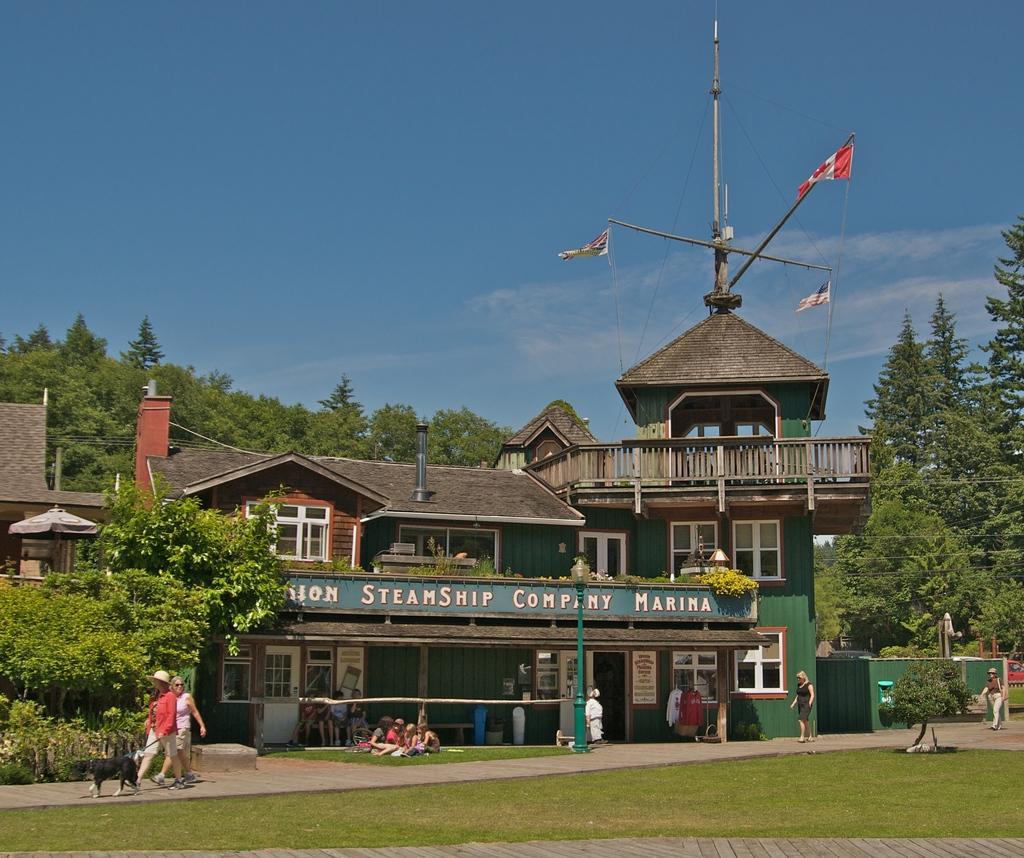Could you give a brief overview of what you see in this image? In this image in the front there's grass on the water. In the center there are persons walking and standing and there is a dog. In the background there are buildings, trees and there are persons sitting and the sky is cloudy and there are flags on the top of the building and there is a tower and there is a car which is red in colour. 